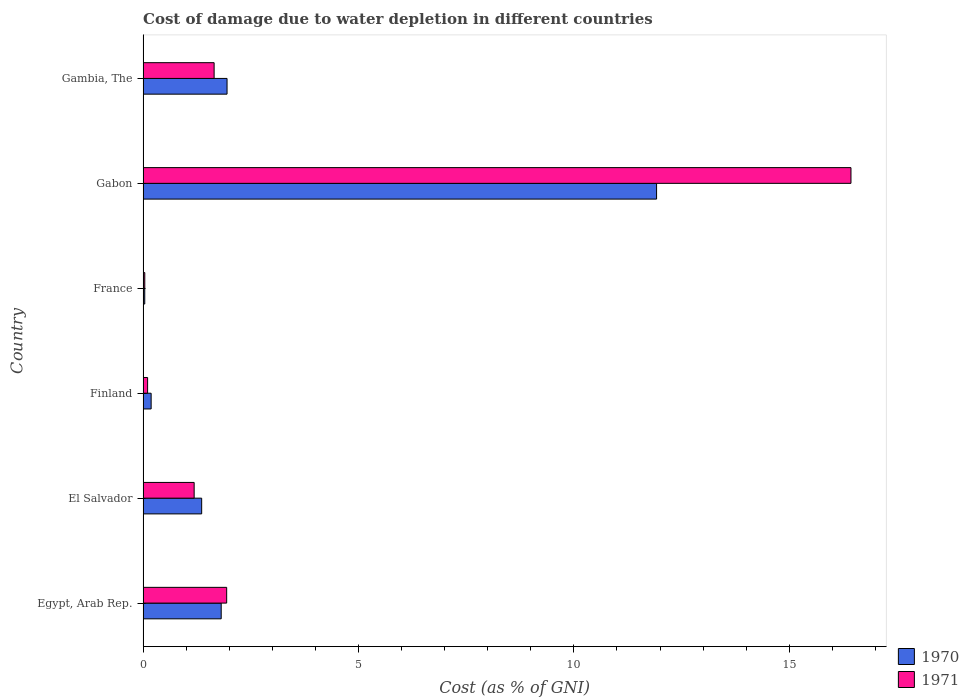Are the number of bars per tick equal to the number of legend labels?
Offer a terse response. Yes. Are the number of bars on each tick of the Y-axis equal?
Give a very brief answer. Yes. How many bars are there on the 4th tick from the bottom?
Your response must be concise. 2. What is the label of the 6th group of bars from the top?
Provide a short and direct response. Egypt, Arab Rep. What is the cost of damage caused due to water depletion in 1970 in Finland?
Your response must be concise. 0.19. Across all countries, what is the maximum cost of damage caused due to water depletion in 1971?
Offer a very short reply. 16.43. Across all countries, what is the minimum cost of damage caused due to water depletion in 1971?
Give a very brief answer. 0.04. In which country was the cost of damage caused due to water depletion in 1970 maximum?
Offer a terse response. Gabon. What is the total cost of damage caused due to water depletion in 1970 in the graph?
Your answer should be very brief. 17.27. What is the difference between the cost of damage caused due to water depletion in 1971 in Finland and that in Gambia, The?
Offer a terse response. -1.54. What is the difference between the cost of damage caused due to water depletion in 1970 in El Salvador and the cost of damage caused due to water depletion in 1971 in France?
Make the answer very short. 1.32. What is the average cost of damage caused due to water depletion in 1971 per country?
Your response must be concise. 3.56. What is the difference between the cost of damage caused due to water depletion in 1970 and cost of damage caused due to water depletion in 1971 in France?
Offer a terse response. -0. What is the ratio of the cost of damage caused due to water depletion in 1970 in Finland to that in Gabon?
Keep it short and to the point. 0.02. Is the cost of damage caused due to water depletion in 1971 in France less than that in Gabon?
Keep it short and to the point. Yes. Is the difference between the cost of damage caused due to water depletion in 1970 in Gabon and Gambia, The greater than the difference between the cost of damage caused due to water depletion in 1971 in Gabon and Gambia, The?
Keep it short and to the point. No. What is the difference between the highest and the second highest cost of damage caused due to water depletion in 1970?
Keep it short and to the point. 9.97. What is the difference between the highest and the lowest cost of damage caused due to water depletion in 1971?
Offer a very short reply. 16.39. Is the sum of the cost of damage caused due to water depletion in 1970 in Finland and Gambia, The greater than the maximum cost of damage caused due to water depletion in 1971 across all countries?
Provide a succinct answer. No. What does the 2nd bar from the top in Gambia, The represents?
Your answer should be compact. 1970. Are all the bars in the graph horizontal?
Keep it short and to the point. Yes. Are the values on the major ticks of X-axis written in scientific E-notation?
Offer a terse response. No. Where does the legend appear in the graph?
Provide a succinct answer. Bottom right. What is the title of the graph?
Ensure brevity in your answer.  Cost of damage due to water depletion in different countries. Does "1971" appear as one of the legend labels in the graph?
Provide a succinct answer. Yes. What is the label or title of the X-axis?
Offer a very short reply. Cost (as % of GNI). What is the Cost (as % of GNI) of 1970 in Egypt, Arab Rep.?
Your answer should be very brief. 1.81. What is the Cost (as % of GNI) in 1971 in Egypt, Arab Rep.?
Offer a very short reply. 1.94. What is the Cost (as % of GNI) in 1970 in El Salvador?
Keep it short and to the point. 1.36. What is the Cost (as % of GNI) of 1971 in El Salvador?
Provide a short and direct response. 1.19. What is the Cost (as % of GNI) of 1970 in Finland?
Provide a short and direct response. 0.19. What is the Cost (as % of GNI) of 1971 in Finland?
Your answer should be compact. 0.11. What is the Cost (as % of GNI) of 1970 in France?
Your answer should be very brief. 0.04. What is the Cost (as % of GNI) of 1971 in France?
Your answer should be very brief. 0.04. What is the Cost (as % of GNI) in 1970 in Gabon?
Offer a terse response. 11.92. What is the Cost (as % of GNI) in 1971 in Gabon?
Make the answer very short. 16.43. What is the Cost (as % of GNI) in 1970 in Gambia, The?
Provide a succinct answer. 1.95. What is the Cost (as % of GNI) in 1971 in Gambia, The?
Provide a short and direct response. 1.65. Across all countries, what is the maximum Cost (as % of GNI) of 1970?
Offer a terse response. 11.92. Across all countries, what is the maximum Cost (as % of GNI) in 1971?
Give a very brief answer. 16.43. Across all countries, what is the minimum Cost (as % of GNI) in 1970?
Offer a very short reply. 0.04. Across all countries, what is the minimum Cost (as % of GNI) of 1971?
Give a very brief answer. 0.04. What is the total Cost (as % of GNI) of 1970 in the graph?
Give a very brief answer. 17.27. What is the total Cost (as % of GNI) in 1971 in the graph?
Make the answer very short. 21.35. What is the difference between the Cost (as % of GNI) of 1970 in Egypt, Arab Rep. and that in El Salvador?
Ensure brevity in your answer.  0.45. What is the difference between the Cost (as % of GNI) of 1971 in Egypt, Arab Rep. and that in El Salvador?
Offer a very short reply. 0.75. What is the difference between the Cost (as % of GNI) in 1970 in Egypt, Arab Rep. and that in Finland?
Your response must be concise. 1.63. What is the difference between the Cost (as % of GNI) of 1971 in Egypt, Arab Rep. and that in Finland?
Provide a succinct answer. 1.84. What is the difference between the Cost (as % of GNI) of 1970 in Egypt, Arab Rep. and that in France?
Your answer should be compact. 1.77. What is the difference between the Cost (as % of GNI) in 1971 in Egypt, Arab Rep. and that in France?
Offer a very short reply. 1.9. What is the difference between the Cost (as % of GNI) of 1970 in Egypt, Arab Rep. and that in Gabon?
Provide a succinct answer. -10.11. What is the difference between the Cost (as % of GNI) of 1971 in Egypt, Arab Rep. and that in Gabon?
Offer a very short reply. -14.49. What is the difference between the Cost (as % of GNI) in 1970 in Egypt, Arab Rep. and that in Gambia, The?
Make the answer very short. -0.14. What is the difference between the Cost (as % of GNI) of 1971 in Egypt, Arab Rep. and that in Gambia, The?
Provide a short and direct response. 0.29. What is the difference between the Cost (as % of GNI) of 1970 in El Salvador and that in Finland?
Your answer should be very brief. 1.17. What is the difference between the Cost (as % of GNI) in 1971 in El Salvador and that in Finland?
Offer a terse response. 1.08. What is the difference between the Cost (as % of GNI) of 1970 in El Salvador and that in France?
Ensure brevity in your answer.  1.32. What is the difference between the Cost (as % of GNI) in 1971 in El Salvador and that in France?
Your response must be concise. 1.15. What is the difference between the Cost (as % of GNI) in 1970 in El Salvador and that in Gabon?
Ensure brevity in your answer.  -10.56. What is the difference between the Cost (as % of GNI) in 1971 in El Salvador and that in Gabon?
Keep it short and to the point. -15.25. What is the difference between the Cost (as % of GNI) in 1970 in El Salvador and that in Gambia, The?
Ensure brevity in your answer.  -0.59. What is the difference between the Cost (as % of GNI) in 1971 in El Salvador and that in Gambia, The?
Keep it short and to the point. -0.46. What is the difference between the Cost (as % of GNI) in 1970 in Finland and that in France?
Your answer should be very brief. 0.15. What is the difference between the Cost (as % of GNI) in 1971 in Finland and that in France?
Your response must be concise. 0.07. What is the difference between the Cost (as % of GNI) of 1970 in Finland and that in Gabon?
Keep it short and to the point. -11.73. What is the difference between the Cost (as % of GNI) of 1971 in Finland and that in Gabon?
Make the answer very short. -16.33. What is the difference between the Cost (as % of GNI) in 1970 in Finland and that in Gambia, The?
Your answer should be very brief. -1.76. What is the difference between the Cost (as % of GNI) of 1971 in Finland and that in Gambia, The?
Provide a succinct answer. -1.54. What is the difference between the Cost (as % of GNI) of 1970 in France and that in Gabon?
Give a very brief answer. -11.88. What is the difference between the Cost (as % of GNI) of 1971 in France and that in Gabon?
Ensure brevity in your answer.  -16.39. What is the difference between the Cost (as % of GNI) in 1970 in France and that in Gambia, The?
Keep it short and to the point. -1.91. What is the difference between the Cost (as % of GNI) in 1971 in France and that in Gambia, The?
Your answer should be compact. -1.61. What is the difference between the Cost (as % of GNI) of 1970 in Gabon and that in Gambia, The?
Offer a terse response. 9.97. What is the difference between the Cost (as % of GNI) of 1971 in Gabon and that in Gambia, The?
Keep it short and to the point. 14.78. What is the difference between the Cost (as % of GNI) in 1970 in Egypt, Arab Rep. and the Cost (as % of GNI) in 1971 in El Salvador?
Give a very brief answer. 0.63. What is the difference between the Cost (as % of GNI) in 1970 in Egypt, Arab Rep. and the Cost (as % of GNI) in 1971 in Finland?
Offer a terse response. 1.71. What is the difference between the Cost (as % of GNI) of 1970 in Egypt, Arab Rep. and the Cost (as % of GNI) of 1971 in France?
Your response must be concise. 1.77. What is the difference between the Cost (as % of GNI) in 1970 in Egypt, Arab Rep. and the Cost (as % of GNI) in 1971 in Gabon?
Provide a short and direct response. -14.62. What is the difference between the Cost (as % of GNI) in 1970 in Egypt, Arab Rep. and the Cost (as % of GNI) in 1971 in Gambia, The?
Make the answer very short. 0.16. What is the difference between the Cost (as % of GNI) in 1970 in El Salvador and the Cost (as % of GNI) in 1971 in Finland?
Provide a short and direct response. 1.25. What is the difference between the Cost (as % of GNI) in 1970 in El Salvador and the Cost (as % of GNI) in 1971 in France?
Your response must be concise. 1.32. What is the difference between the Cost (as % of GNI) in 1970 in El Salvador and the Cost (as % of GNI) in 1971 in Gabon?
Your response must be concise. -15.07. What is the difference between the Cost (as % of GNI) of 1970 in El Salvador and the Cost (as % of GNI) of 1971 in Gambia, The?
Provide a short and direct response. -0.29. What is the difference between the Cost (as % of GNI) in 1970 in Finland and the Cost (as % of GNI) in 1971 in France?
Keep it short and to the point. 0.15. What is the difference between the Cost (as % of GNI) in 1970 in Finland and the Cost (as % of GNI) in 1971 in Gabon?
Ensure brevity in your answer.  -16.24. What is the difference between the Cost (as % of GNI) in 1970 in Finland and the Cost (as % of GNI) in 1971 in Gambia, The?
Your answer should be very brief. -1.46. What is the difference between the Cost (as % of GNI) of 1970 in France and the Cost (as % of GNI) of 1971 in Gabon?
Make the answer very short. -16.39. What is the difference between the Cost (as % of GNI) of 1970 in France and the Cost (as % of GNI) of 1971 in Gambia, The?
Provide a succinct answer. -1.61. What is the difference between the Cost (as % of GNI) of 1970 in Gabon and the Cost (as % of GNI) of 1971 in Gambia, The?
Your answer should be very brief. 10.27. What is the average Cost (as % of GNI) of 1970 per country?
Ensure brevity in your answer.  2.88. What is the average Cost (as % of GNI) in 1971 per country?
Offer a very short reply. 3.56. What is the difference between the Cost (as % of GNI) of 1970 and Cost (as % of GNI) of 1971 in Egypt, Arab Rep.?
Offer a very short reply. -0.13. What is the difference between the Cost (as % of GNI) of 1970 and Cost (as % of GNI) of 1971 in El Salvador?
Ensure brevity in your answer.  0.17. What is the difference between the Cost (as % of GNI) of 1970 and Cost (as % of GNI) of 1971 in Finland?
Offer a very short reply. 0.08. What is the difference between the Cost (as % of GNI) in 1970 and Cost (as % of GNI) in 1971 in France?
Your answer should be very brief. -0. What is the difference between the Cost (as % of GNI) in 1970 and Cost (as % of GNI) in 1971 in Gabon?
Offer a terse response. -4.51. What is the ratio of the Cost (as % of GNI) in 1970 in Egypt, Arab Rep. to that in El Salvador?
Keep it short and to the point. 1.33. What is the ratio of the Cost (as % of GNI) of 1971 in Egypt, Arab Rep. to that in El Salvador?
Make the answer very short. 1.64. What is the ratio of the Cost (as % of GNI) of 1970 in Egypt, Arab Rep. to that in Finland?
Offer a terse response. 9.67. What is the ratio of the Cost (as % of GNI) in 1971 in Egypt, Arab Rep. to that in Finland?
Give a very brief answer. 18.42. What is the ratio of the Cost (as % of GNI) in 1970 in Egypt, Arab Rep. to that in France?
Make the answer very short. 46.14. What is the ratio of the Cost (as % of GNI) in 1971 in Egypt, Arab Rep. to that in France?
Your response must be concise. 48.73. What is the ratio of the Cost (as % of GNI) of 1970 in Egypt, Arab Rep. to that in Gabon?
Provide a short and direct response. 0.15. What is the ratio of the Cost (as % of GNI) of 1971 in Egypt, Arab Rep. to that in Gabon?
Keep it short and to the point. 0.12. What is the ratio of the Cost (as % of GNI) of 1970 in Egypt, Arab Rep. to that in Gambia, The?
Your answer should be very brief. 0.93. What is the ratio of the Cost (as % of GNI) of 1971 in Egypt, Arab Rep. to that in Gambia, The?
Keep it short and to the point. 1.18. What is the ratio of the Cost (as % of GNI) in 1970 in El Salvador to that in Finland?
Provide a short and direct response. 7.25. What is the ratio of the Cost (as % of GNI) in 1971 in El Salvador to that in Finland?
Offer a very short reply. 11.25. What is the ratio of the Cost (as % of GNI) in 1970 in El Salvador to that in France?
Your answer should be compact. 34.6. What is the ratio of the Cost (as % of GNI) of 1971 in El Salvador to that in France?
Keep it short and to the point. 29.78. What is the ratio of the Cost (as % of GNI) of 1970 in El Salvador to that in Gabon?
Your response must be concise. 0.11. What is the ratio of the Cost (as % of GNI) in 1971 in El Salvador to that in Gabon?
Make the answer very short. 0.07. What is the ratio of the Cost (as % of GNI) in 1970 in El Salvador to that in Gambia, The?
Your answer should be compact. 0.7. What is the ratio of the Cost (as % of GNI) in 1971 in El Salvador to that in Gambia, The?
Ensure brevity in your answer.  0.72. What is the ratio of the Cost (as % of GNI) of 1970 in Finland to that in France?
Offer a terse response. 4.77. What is the ratio of the Cost (as % of GNI) in 1971 in Finland to that in France?
Your response must be concise. 2.65. What is the ratio of the Cost (as % of GNI) of 1970 in Finland to that in Gabon?
Provide a short and direct response. 0.02. What is the ratio of the Cost (as % of GNI) in 1971 in Finland to that in Gabon?
Offer a very short reply. 0.01. What is the ratio of the Cost (as % of GNI) of 1970 in Finland to that in Gambia, The?
Give a very brief answer. 0.1. What is the ratio of the Cost (as % of GNI) of 1971 in Finland to that in Gambia, The?
Provide a succinct answer. 0.06. What is the ratio of the Cost (as % of GNI) in 1970 in France to that in Gabon?
Give a very brief answer. 0. What is the ratio of the Cost (as % of GNI) of 1971 in France to that in Gabon?
Provide a succinct answer. 0. What is the ratio of the Cost (as % of GNI) in 1970 in France to that in Gambia, The?
Provide a succinct answer. 0.02. What is the ratio of the Cost (as % of GNI) of 1971 in France to that in Gambia, The?
Offer a terse response. 0.02. What is the ratio of the Cost (as % of GNI) in 1970 in Gabon to that in Gambia, The?
Give a very brief answer. 6.11. What is the ratio of the Cost (as % of GNI) in 1971 in Gabon to that in Gambia, The?
Give a very brief answer. 9.96. What is the difference between the highest and the second highest Cost (as % of GNI) of 1970?
Ensure brevity in your answer.  9.97. What is the difference between the highest and the second highest Cost (as % of GNI) in 1971?
Offer a terse response. 14.49. What is the difference between the highest and the lowest Cost (as % of GNI) in 1970?
Keep it short and to the point. 11.88. What is the difference between the highest and the lowest Cost (as % of GNI) of 1971?
Give a very brief answer. 16.39. 